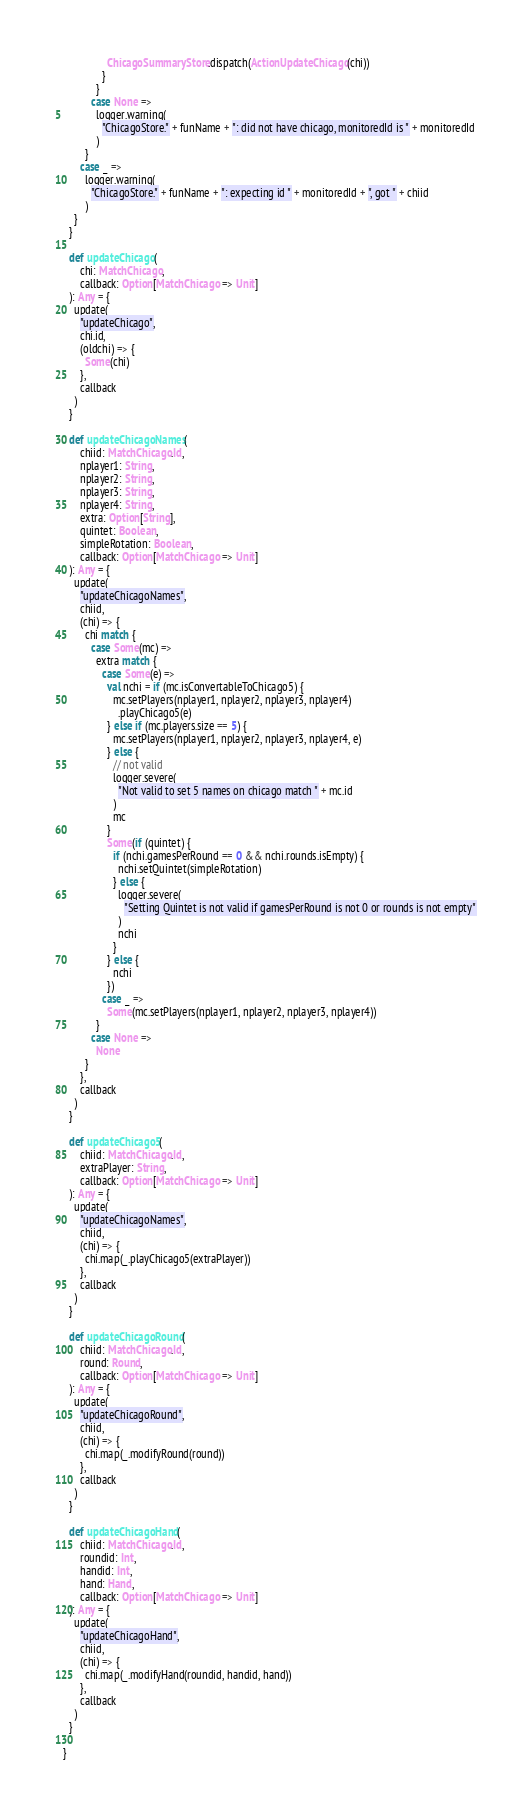<code> <loc_0><loc_0><loc_500><loc_500><_Scala_>                ChicagoSummaryStore.dispatch(ActionUpdateChicago(chi))
              }
            }
          case None =>
            logger.warning(
              "ChicagoStore." + funName + ": did not have chicago, monitoredId is " + monitoredId
            )
        }
      case _ =>
        logger.warning(
          "ChicagoStore." + funName + ": expecting id " + monitoredId + ", got " + chiid
        )
    }
  }

  def updateChicago(
      chi: MatchChicago,
      callback: Option[MatchChicago => Unit]
  ): Any = {
    update(
      "updateChicago",
      chi.id,
      (oldchi) => {
        Some(chi)
      },
      callback
    )
  }

  def updateChicagoNames(
      chiid: MatchChicago.Id,
      nplayer1: String,
      nplayer2: String,
      nplayer3: String,
      nplayer4: String,
      extra: Option[String],
      quintet: Boolean,
      simpleRotation: Boolean,
      callback: Option[MatchChicago => Unit]
  ): Any = {
    update(
      "updateChicagoNames",
      chiid,
      (chi) => {
        chi match {
          case Some(mc) =>
            extra match {
              case Some(e) =>
                val nchi = if (mc.isConvertableToChicago5) {
                  mc.setPlayers(nplayer1, nplayer2, nplayer3, nplayer4)
                    .playChicago5(e)
                } else if (mc.players.size == 5) {
                  mc.setPlayers(nplayer1, nplayer2, nplayer3, nplayer4, e)
                } else {
                  // not valid
                  logger.severe(
                    "Not valid to set 5 names on chicago match " + mc.id
                  )
                  mc
                }
                Some(if (quintet) {
                  if (nchi.gamesPerRound == 0 && nchi.rounds.isEmpty) {
                    nchi.setQuintet(simpleRotation)
                  } else {
                    logger.severe(
                      "Setting Quintet is not valid if gamesPerRound is not 0 or rounds is not empty"
                    )
                    nchi
                  }
                } else {
                  nchi
                })
              case _ =>
                Some(mc.setPlayers(nplayer1, nplayer2, nplayer3, nplayer4))
            }
          case None =>
            None
        }
      },
      callback
    )
  }

  def updateChicago5(
      chiid: MatchChicago.Id,
      extraPlayer: String,
      callback: Option[MatchChicago => Unit]
  ): Any = {
    update(
      "updateChicagoNames",
      chiid,
      (chi) => {
        chi.map(_.playChicago5(extraPlayer))
      },
      callback
    )
  }

  def updateChicagoRound(
      chiid: MatchChicago.Id,
      round: Round,
      callback: Option[MatchChicago => Unit]
  ): Any = {
    update(
      "updateChicagoRound",
      chiid,
      (chi) => {
        chi.map(_.modifyRound(round))
      },
      callback
    )
  }

  def updateChicagoHand(
      chiid: MatchChicago.Id,
      roundid: Int,
      handid: Int,
      hand: Hand,
      callback: Option[MatchChicago => Unit]
  ): Any = {
    update(
      "updateChicagoHand",
      chiid,
      (chi) => {
        chi.map(_.modifyHand(roundid, handid, hand))
      },
      callback
    )
  }

}
</code> 